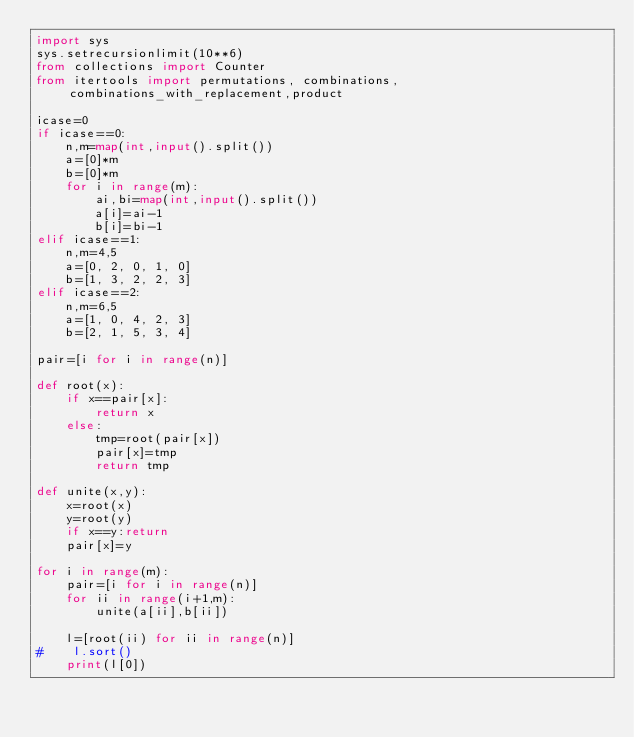<code> <loc_0><loc_0><loc_500><loc_500><_Python_>import sys
sys.setrecursionlimit(10**6)
from collections import Counter
from itertools import permutations, combinations,combinations_with_replacement,product

icase=0
if icase==0:
    n,m=map(int,input().split())
    a=[0]*m
    b=[0]*m
    for i in range(m):
        ai,bi=map(int,input().split())
        a[i]=ai-1
        b[i]=bi-1
elif icase==1:
    n,m=4,5
    a=[0, 2, 0, 1, 0]
    b=[1, 3, 2, 2, 3]
elif icase==2:
    n,m=6,5
    a=[1, 0, 4, 2, 3]
    b=[2, 1, 5, 3, 4]

pair=[i for i in range(n)]

def root(x):
    if x==pair[x]:
        return x
    else:
        tmp=root(pair[x])
        pair[x]=tmp
        return tmp

def unite(x,y):
    x=root(x)
    y=root(y)
    if x==y:return
    pair[x]=y

for i in range(m):
    pair=[i for i in range(n)]
    for ii in range(i+1,m):
        unite(a[ii],b[ii])

    l=[root(ii) for ii in range(n)]
#    l.sort()
    print(l[0])
</code> 